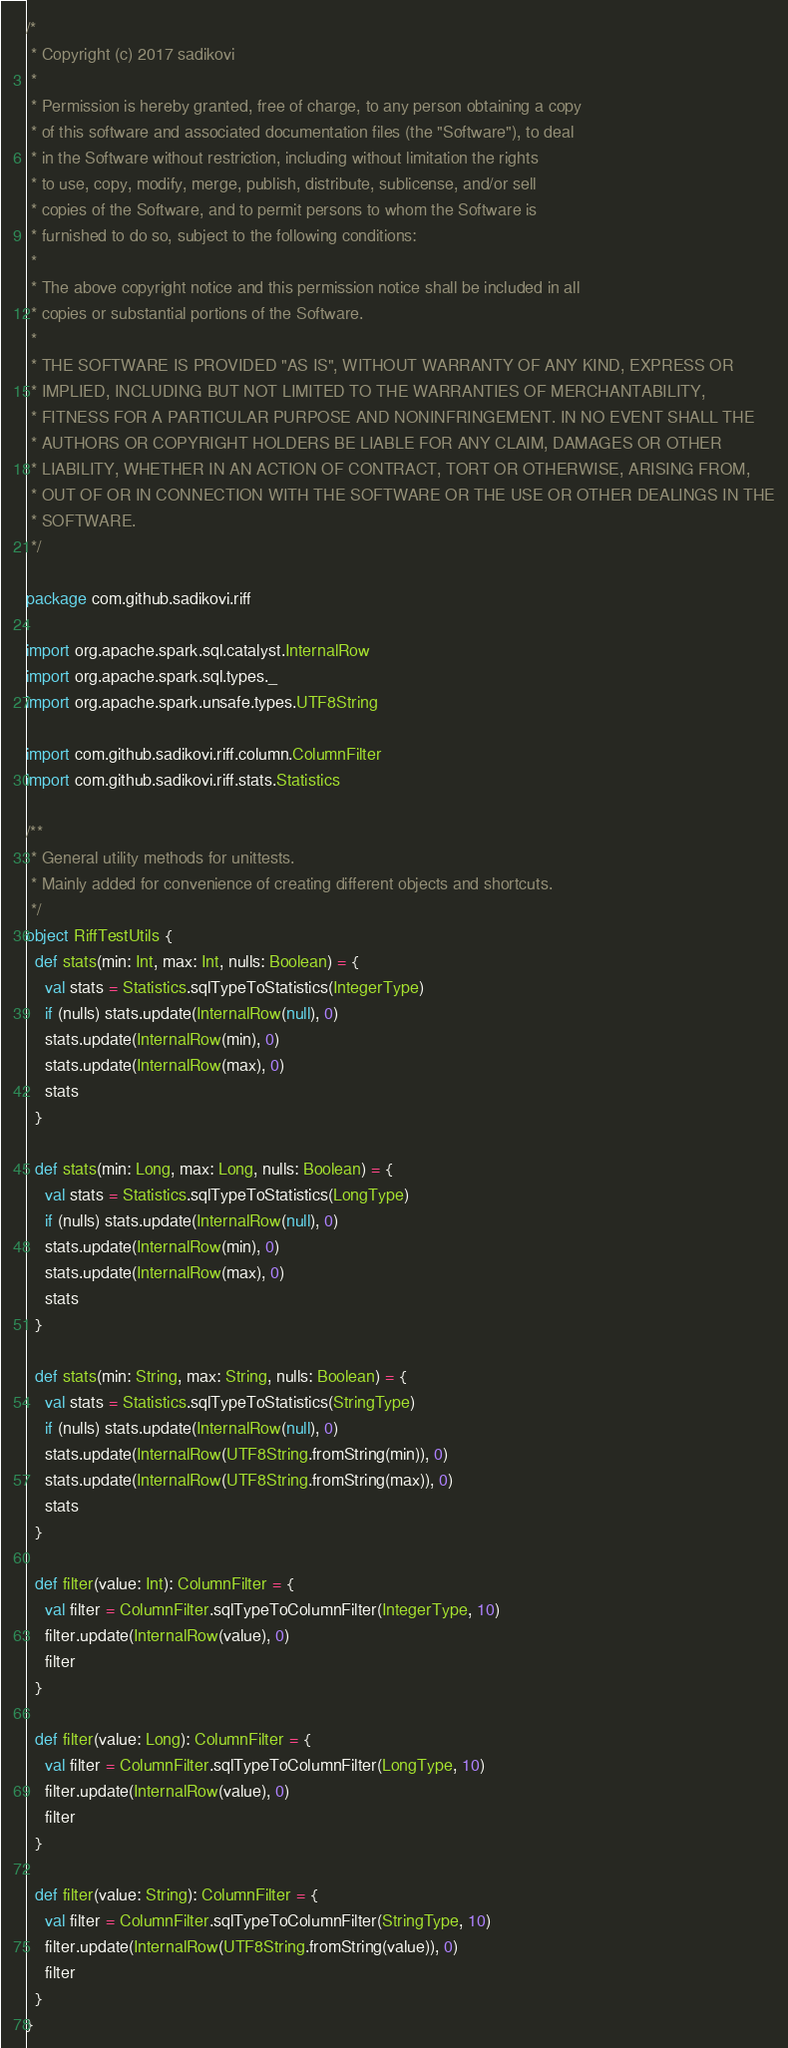Convert code to text. <code><loc_0><loc_0><loc_500><loc_500><_Scala_>/*
 * Copyright (c) 2017 sadikovi
 *
 * Permission is hereby granted, free of charge, to any person obtaining a copy
 * of this software and associated documentation files (the "Software"), to deal
 * in the Software without restriction, including without limitation the rights
 * to use, copy, modify, merge, publish, distribute, sublicense, and/or sell
 * copies of the Software, and to permit persons to whom the Software is
 * furnished to do so, subject to the following conditions:
 *
 * The above copyright notice and this permission notice shall be included in all
 * copies or substantial portions of the Software.
 *
 * THE SOFTWARE IS PROVIDED "AS IS", WITHOUT WARRANTY OF ANY KIND, EXPRESS OR
 * IMPLIED, INCLUDING BUT NOT LIMITED TO THE WARRANTIES OF MERCHANTABILITY,
 * FITNESS FOR A PARTICULAR PURPOSE AND NONINFRINGEMENT. IN NO EVENT SHALL THE
 * AUTHORS OR COPYRIGHT HOLDERS BE LIABLE FOR ANY CLAIM, DAMAGES OR OTHER
 * LIABILITY, WHETHER IN AN ACTION OF CONTRACT, TORT OR OTHERWISE, ARISING FROM,
 * OUT OF OR IN CONNECTION WITH THE SOFTWARE OR THE USE OR OTHER DEALINGS IN THE
 * SOFTWARE.
 */

package com.github.sadikovi.riff

import org.apache.spark.sql.catalyst.InternalRow
import org.apache.spark.sql.types._
import org.apache.spark.unsafe.types.UTF8String

import com.github.sadikovi.riff.column.ColumnFilter
import com.github.sadikovi.riff.stats.Statistics

/**
 * General utility methods for unittests.
 * Mainly added for convenience of creating different objects and shortcuts.
 */
object RiffTestUtils {
  def stats(min: Int, max: Int, nulls: Boolean) = {
    val stats = Statistics.sqlTypeToStatistics(IntegerType)
    if (nulls) stats.update(InternalRow(null), 0)
    stats.update(InternalRow(min), 0)
    stats.update(InternalRow(max), 0)
    stats
  }

  def stats(min: Long, max: Long, nulls: Boolean) = {
    val stats = Statistics.sqlTypeToStatistics(LongType)
    if (nulls) stats.update(InternalRow(null), 0)
    stats.update(InternalRow(min), 0)
    stats.update(InternalRow(max), 0)
    stats
  }

  def stats(min: String, max: String, nulls: Boolean) = {
    val stats = Statistics.sqlTypeToStatistics(StringType)
    if (nulls) stats.update(InternalRow(null), 0)
    stats.update(InternalRow(UTF8String.fromString(min)), 0)
    stats.update(InternalRow(UTF8String.fromString(max)), 0)
    stats
  }

  def filter(value: Int): ColumnFilter = {
    val filter = ColumnFilter.sqlTypeToColumnFilter(IntegerType, 10)
    filter.update(InternalRow(value), 0)
    filter
  }

  def filter(value: Long): ColumnFilter = {
    val filter = ColumnFilter.sqlTypeToColumnFilter(LongType, 10)
    filter.update(InternalRow(value), 0)
    filter
  }

  def filter(value: String): ColumnFilter = {
    val filter = ColumnFilter.sqlTypeToColumnFilter(StringType, 10)
    filter.update(InternalRow(UTF8String.fromString(value)), 0)
    filter
  }
}
</code> 